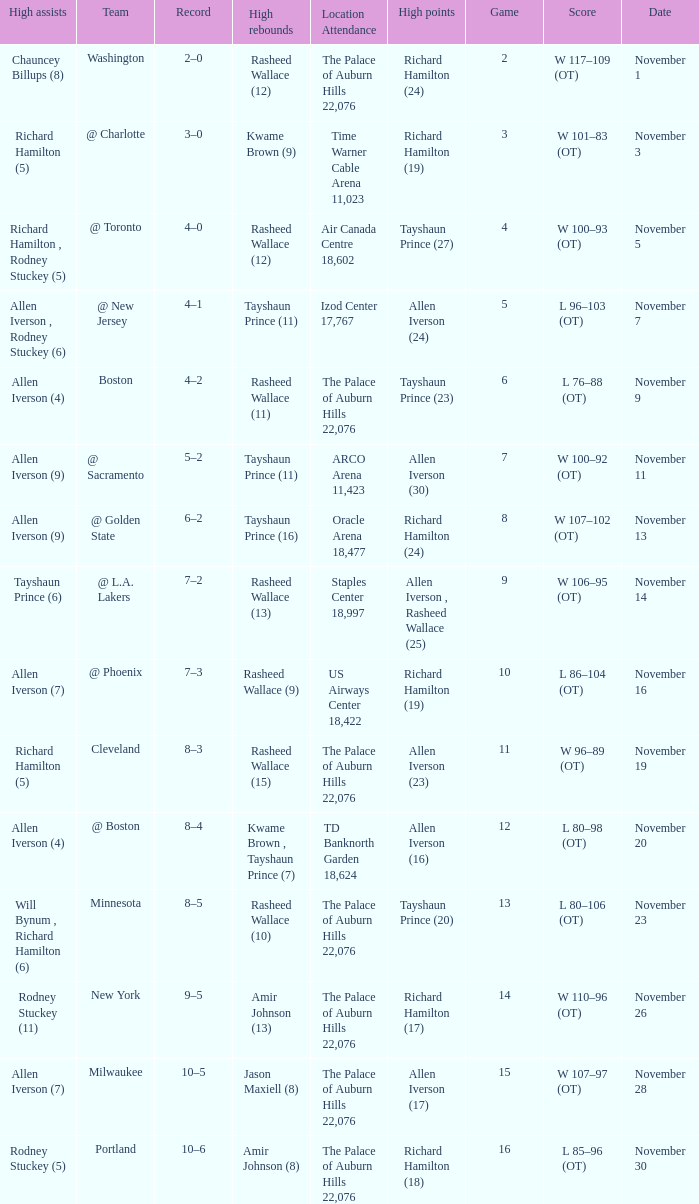What is the average Game, when Team is "Milwaukee"? 15.0. 